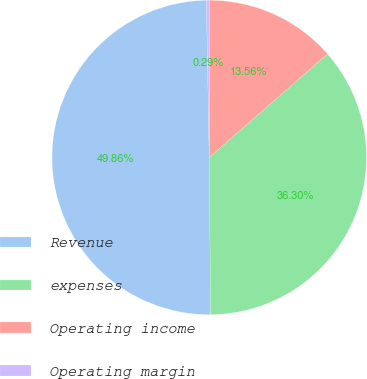Convert chart to OTSL. <chart><loc_0><loc_0><loc_500><loc_500><pie_chart><fcel>Revenue<fcel>expenses<fcel>Operating income<fcel>Operating margin<nl><fcel>49.86%<fcel>36.3%<fcel>13.56%<fcel>0.29%<nl></chart> 